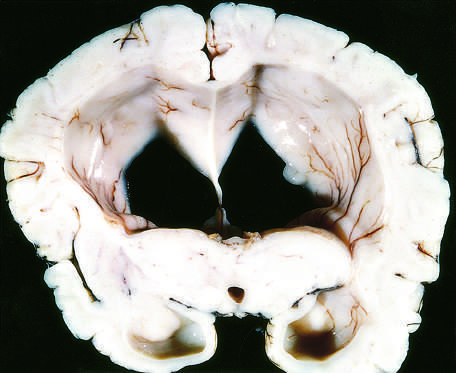re varices associated with a dangerous increase in intra-cranial pressure?
Answer the question using a single word or phrase. No 